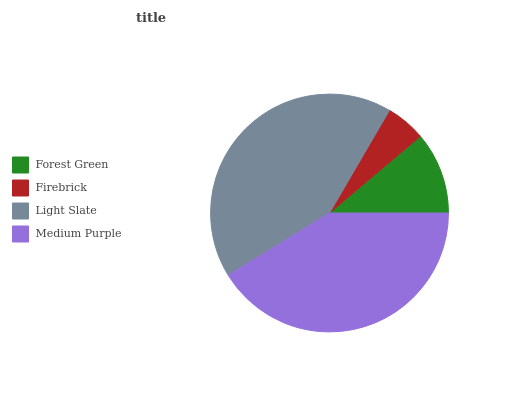Is Firebrick the minimum?
Answer yes or no. Yes. Is Light Slate the maximum?
Answer yes or no. Yes. Is Light Slate the minimum?
Answer yes or no. No. Is Firebrick the maximum?
Answer yes or no. No. Is Light Slate greater than Firebrick?
Answer yes or no. Yes. Is Firebrick less than Light Slate?
Answer yes or no. Yes. Is Firebrick greater than Light Slate?
Answer yes or no. No. Is Light Slate less than Firebrick?
Answer yes or no. No. Is Medium Purple the high median?
Answer yes or no. Yes. Is Forest Green the low median?
Answer yes or no. Yes. Is Firebrick the high median?
Answer yes or no. No. Is Medium Purple the low median?
Answer yes or no. No. 